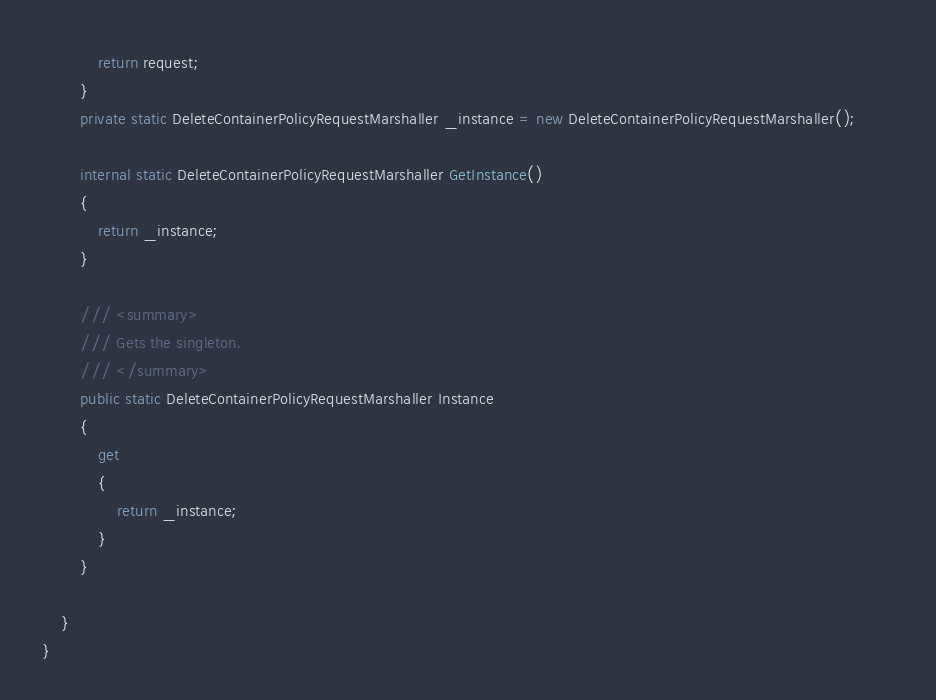<code> <loc_0><loc_0><loc_500><loc_500><_C#_>
            return request;
        }
        private static DeleteContainerPolicyRequestMarshaller _instance = new DeleteContainerPolicyRequestMarshaller();        

        internal static DeleteContainerPolicyRequestMarshaller GetInstance()
        {
            return _instance;
        }

        /// <summary>
        /// Gets the singleton.
        /// </summary>  
        public static DeleteContainerPolicyRequestMarshaller Instance
        {
            get
            {
                return _instance;
            }
        }

    }
}</code> 